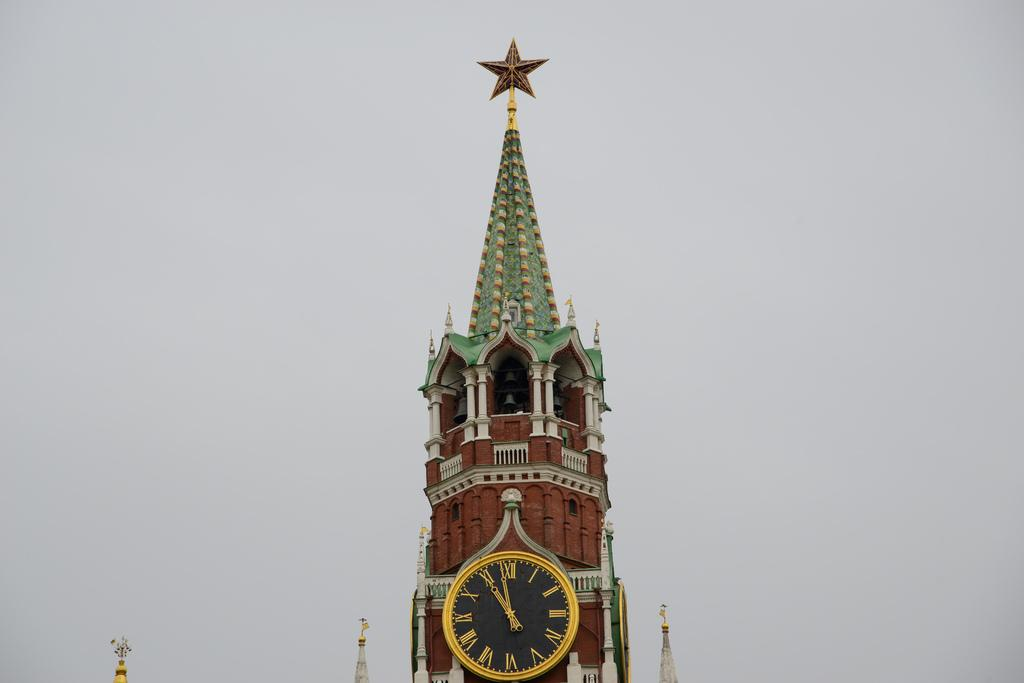What is the main subject in the center of the image? There is a clock tower in the center of the image. What can be seen in the background of the image? Sky is visible in the background of the image. What type of arch can be heard in the image? There is no audible sound, such as an arch, present in the image. 